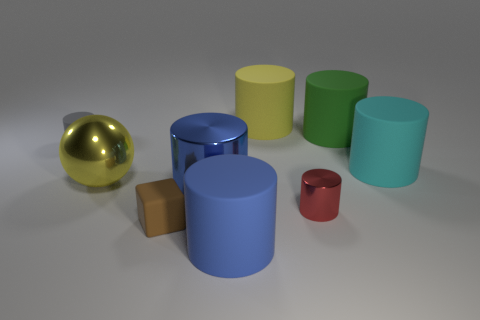How many other objects are there of the same color as the large ball?
Offer a very short reply. 1. Is the number of big things that are behind the large cyan rubber thing greater than the number of yellow matte cylinders to the left of the blue rubber cylinder?
Offer a terse response. Yes. The tiny rubber thing in front of the small thing that is on the left side of the tiny brown matte thing is what color?
Your answer should be compact. Brown. What number of cylinders are red shiny things or cyan rubber things?
Your response must be concise. 2. How many cylinders are both on the left side of the big yellow rubber cylinder and in front of the cyan rubber cylinder?
Provide a succinct answer. 2. What is the color of the matte cylinder that is in front of the cyan object?
Offer a terse response. Blue. The gray cylinder that is the same material as the small cube is what size?
Ensure brevity in your answer.  Small. What number of red shiny cylinders are left of the big blue cylinder that is in front of the small red metallic object?
Offer a terse response. 0. There is a cyan rubber object; what number of matte things are right of it?
Your response must be concise. 0. The small rubber object behind the large cylinder that is right of the big green matte object that is to the right of the red metal cylinder is what color?
Offer a terse response. Gray. 